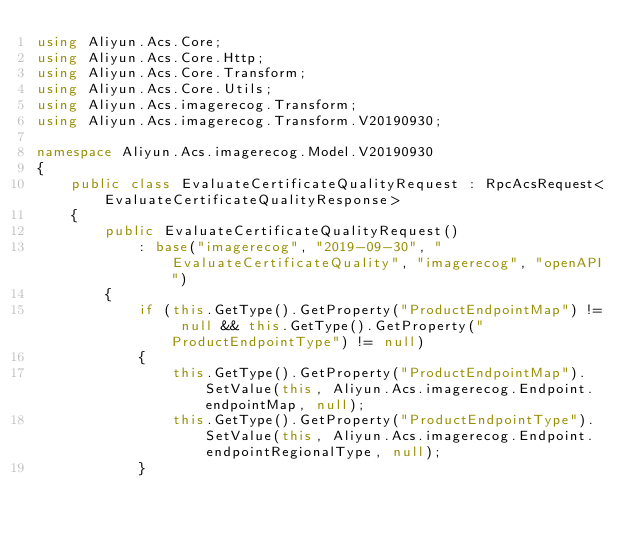Convert code to text. <code><loc_0><loc_0><loc_500><loc_500><_C#_>using Aliyun.Acs.Core;
using Aliyun.Acs.Core.Http;
using Aliyun.Acs.Core.Transform;
using Aliyun.Acs.Core.Utils;
using Aliyun.Acs.imagerecog.Transform;
using Aliyun.Acs.imagerecog.Transform.V20190930;

namespace Aliyun.Acs.imagerecog.Model.V20190930
{
    public class EvaluateCertificateQualityRequest : RpcAcsRequest<EvaluateCertificateQualityResponse>
    {
        public EvaluateCertificateQualityRequest()
            : base("imagerecog", "2019-09-30", "EvaluateCertificateQuality", "imagerecog", "openAPI")
        {
            if (this.GetType().GetProperty("ProductEndpointMap") != null && this.GetType().GetProperty("ProductEndpointType") != null)
            {
                this.GetType().GetProperty("ProductEndpointMap").SetValue(this, Aliyun.Acs.imagerecog.Endpoint.endpointMap, null);
                this.GetType().GetProperty("ProductEndpointType").SetValue(this, Aliyun.Acs.imagerecog.Endpoint.endpointRegionalType, null);
            }</code> 